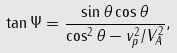Convert formula to latex. <formula><loc_0><loc_0><loc_500><loc_500>\tan \Psi = \frac { \sin \theta \cos \theta } { \cos ^ { 2 } \theta - v _ { p } ^ { 2 } / V _ { A } ^ { 2 } } ,</formula> 